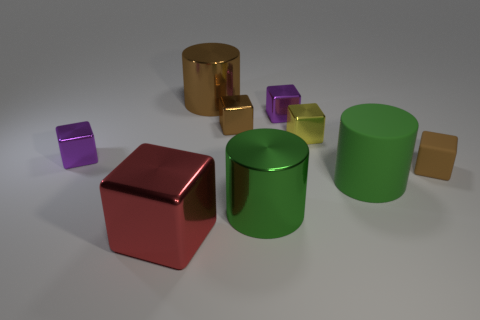How many red objects are either matte things or shiny cubes?
Make the answer very short. 1. There is a tiny cube that is to the left of the red thing; does it have the same color as the small metal block behind the tiny brown metal block?
Offer a very short reply. Yes. There is a small object that is on the left side of the cylinder that is on the left side of the big shiny cylinder that is in front of the large brown thing; what is its color?
Provide a succinct answer. Purple. There is a yellow thing that is behind the brown matte cube; are there any cubes right of it?
Your answer should be compact. Yes. Does the big object right of the large green shiny thing have the same shape as the green metallic object?
Keep it short and to the point. Yes. What number of cylinders are large matte things or tiny purple shiny things?
Provide a short and direct response. 1. How many tiny blue matte spheres are there?
Your answer should be compact. 0. How big is the block in front of the brown block that is in front of the yellow metallic block?
Offer a very short reply. Large. How many other things are the same size as the green metal object?
Offer a very short reply. 3. There is a big block; what number of red shiny cubes are in front of it?
Make the answer very short. 0. 